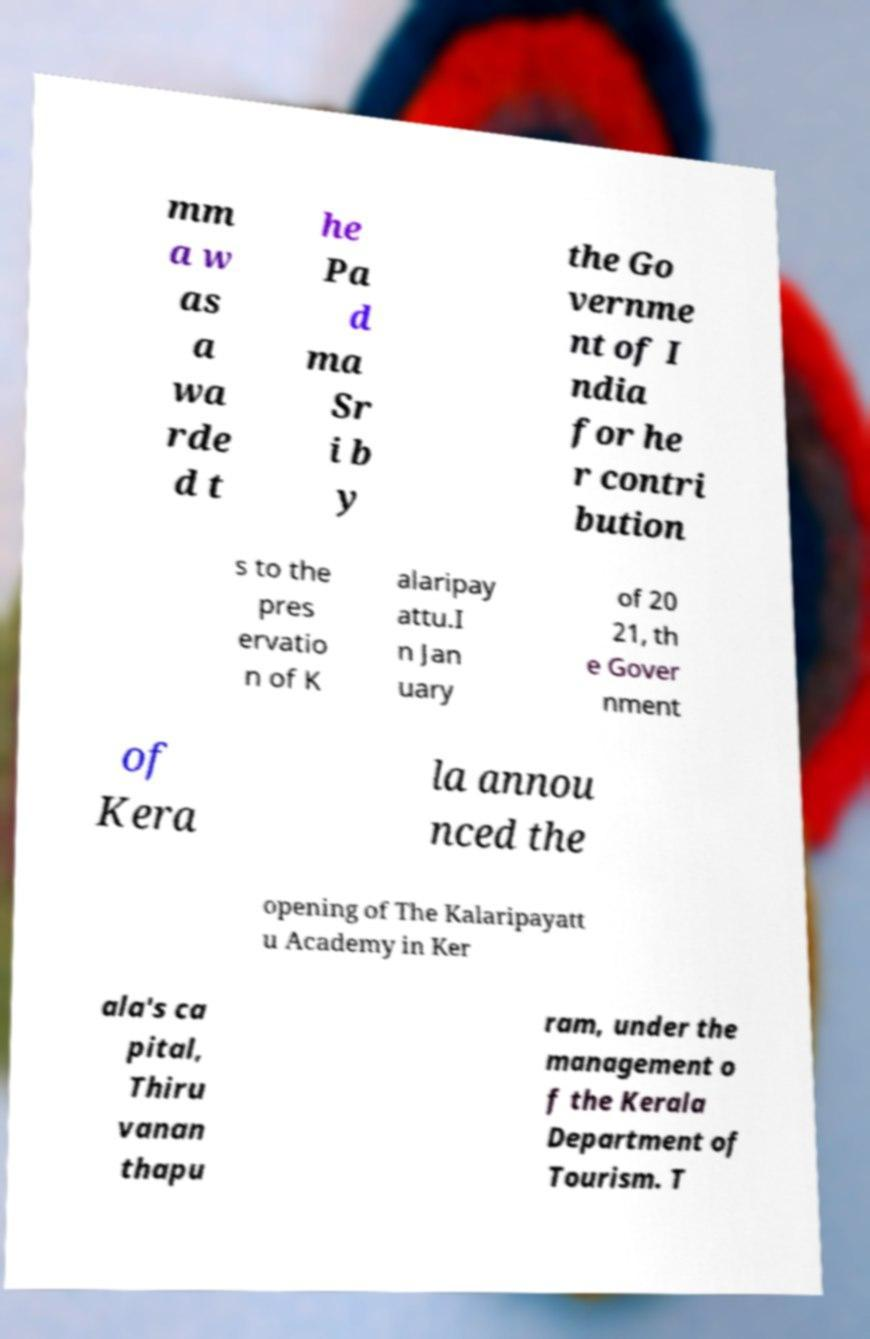For documentation purposes, I need the text within this image transcribed. Could you provide that? mm a w as a wa rde d t he Pa d ma Sr i b y the Go vernme nt of I ndia for he r contri bution s to the pres ervatio n of K alaripay attu.I n Jan uary of 20 21, th e Gover nment of Kera la annou nced the opening of The Kalaripayatt u Academy in Ker ala's ca pital, Thiru vanan thapu ram, under the management o f the Kerala Department of Tourism. T 